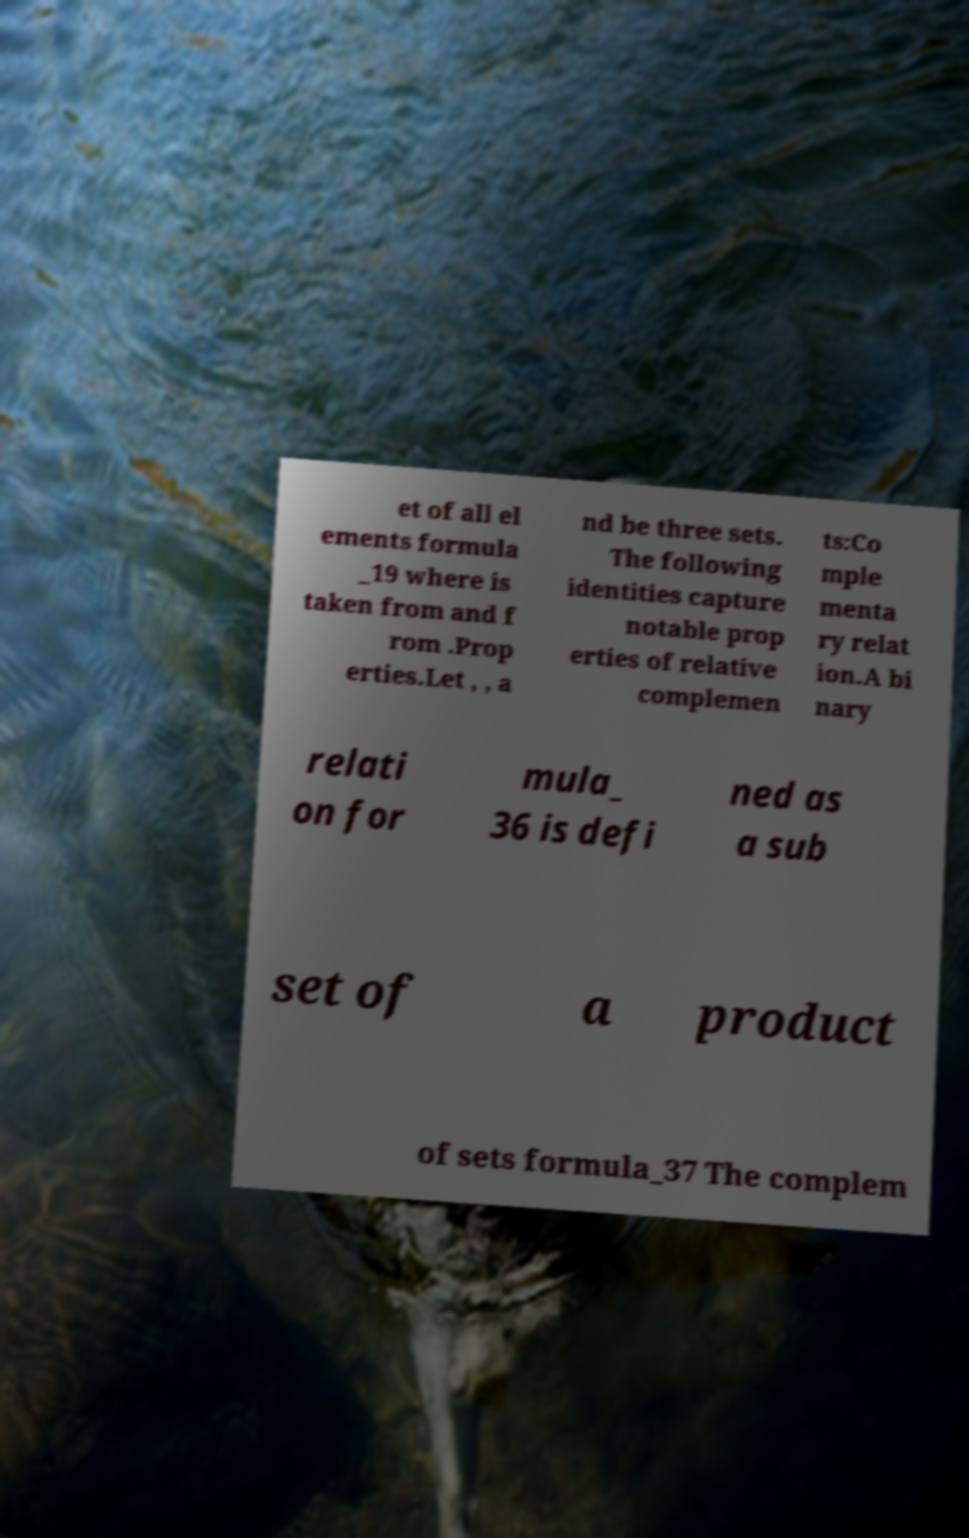I need the written content from this picture converted into text. Can you do that? et of all el ements formula _19 where is taken from and f rom .Prop erties.Let , , a nd be three sets. The following identities capture notable prop erties of relative complemen ts:Co mple menta ry relat ion.A bi nary relati on for mula_ 36 is defi ned as a sub set of a product of sets formula_37 The complem 